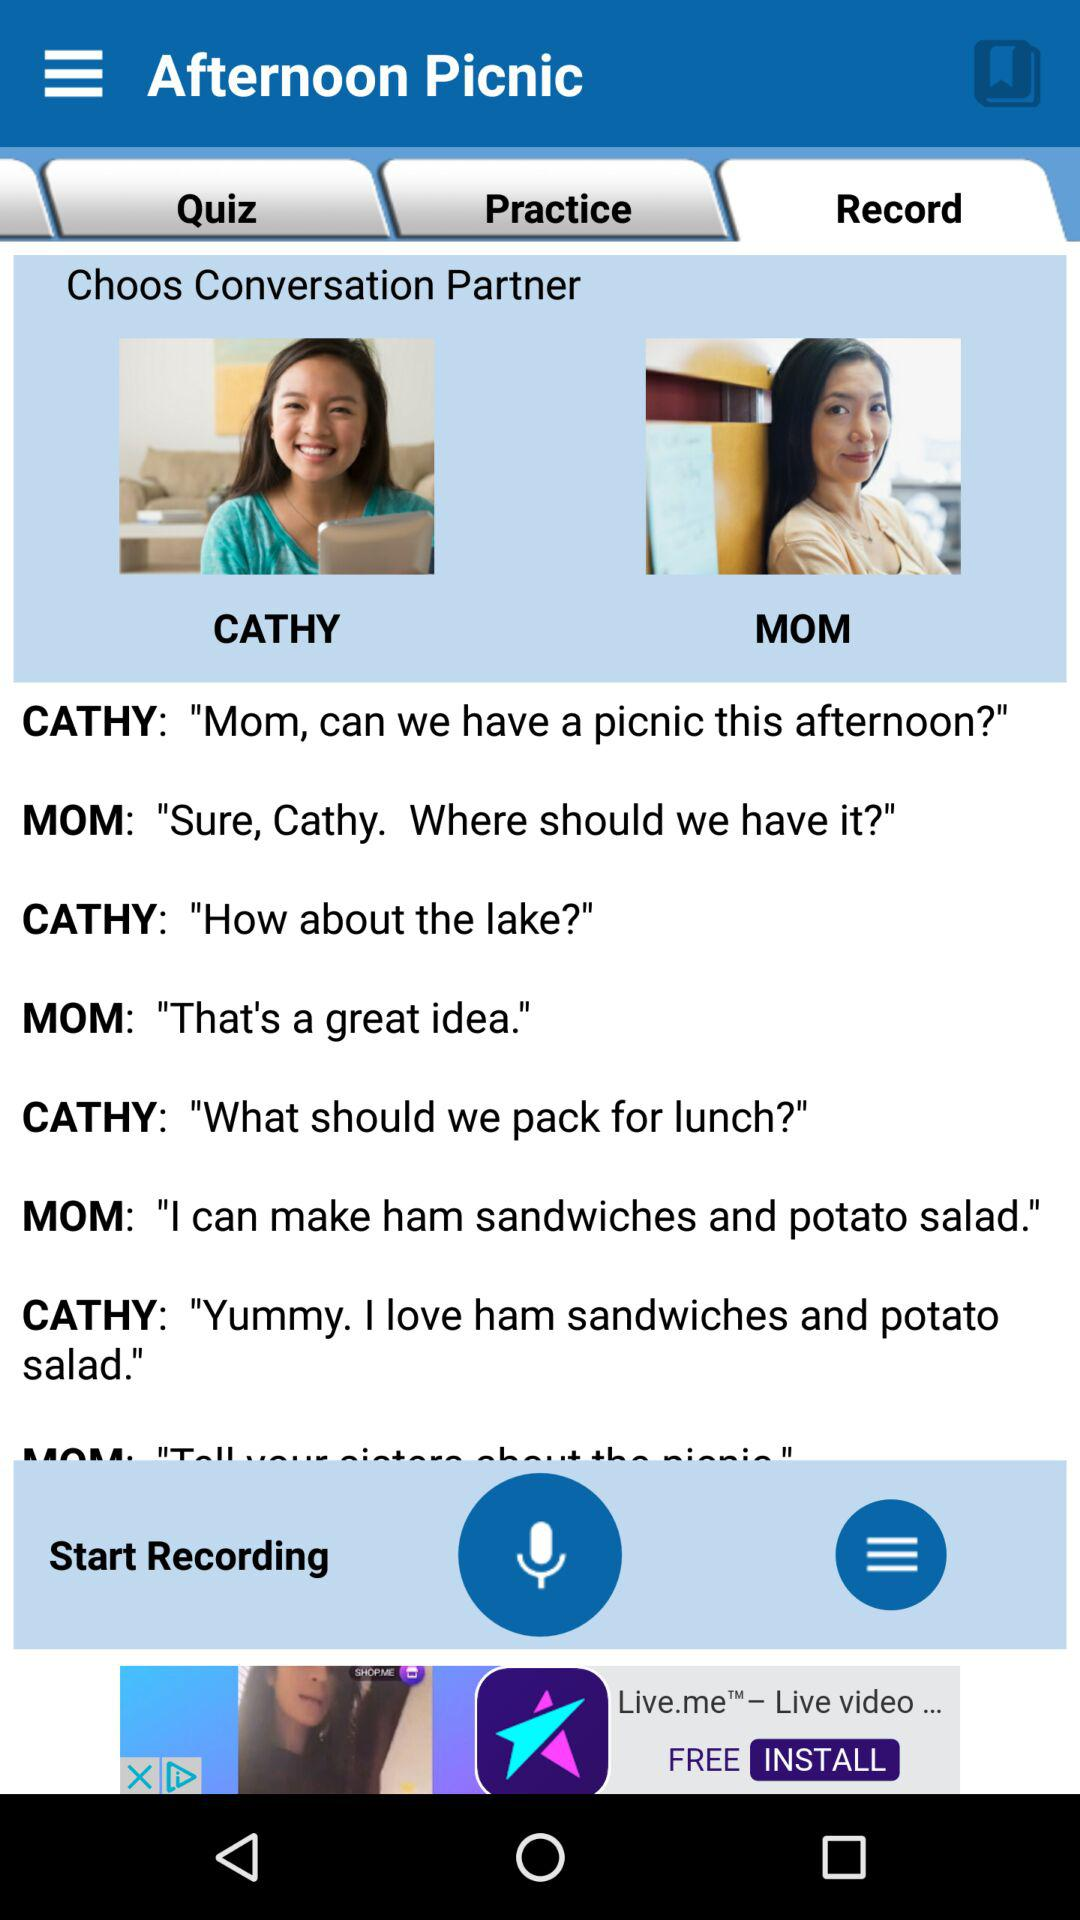Which tab is selected? The selected tab is "Record". 